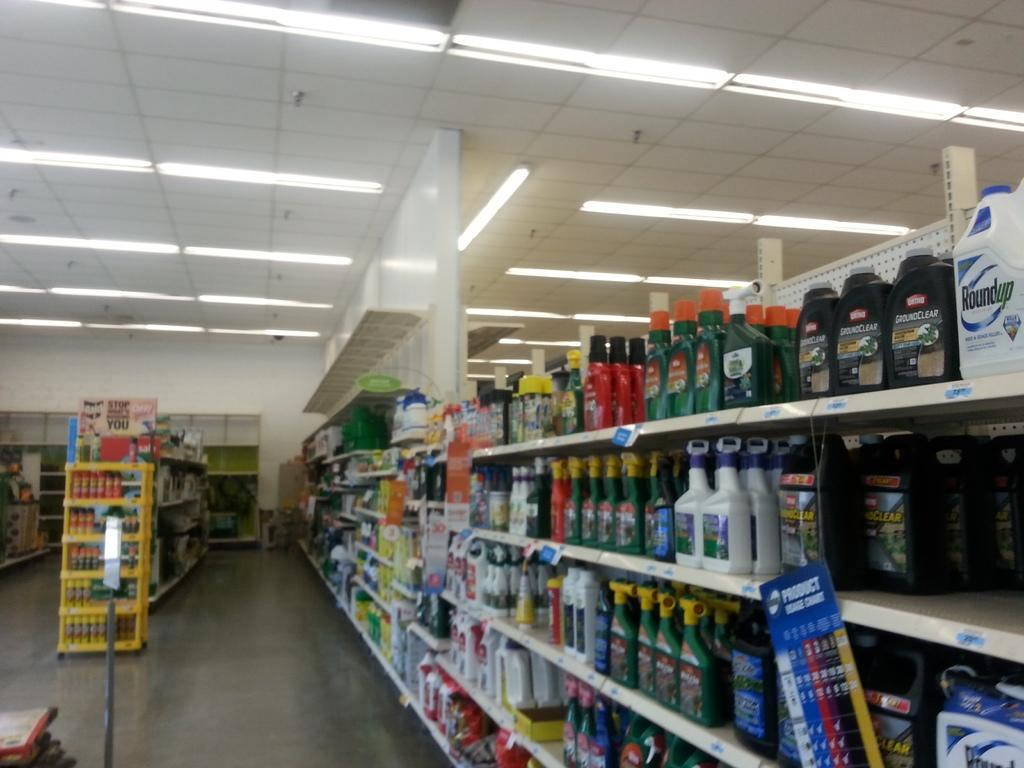<image>
Render a clear and concise summary of the photo. Chemicals aisle shows a bottle of roundup on top of the shelf on the right. 